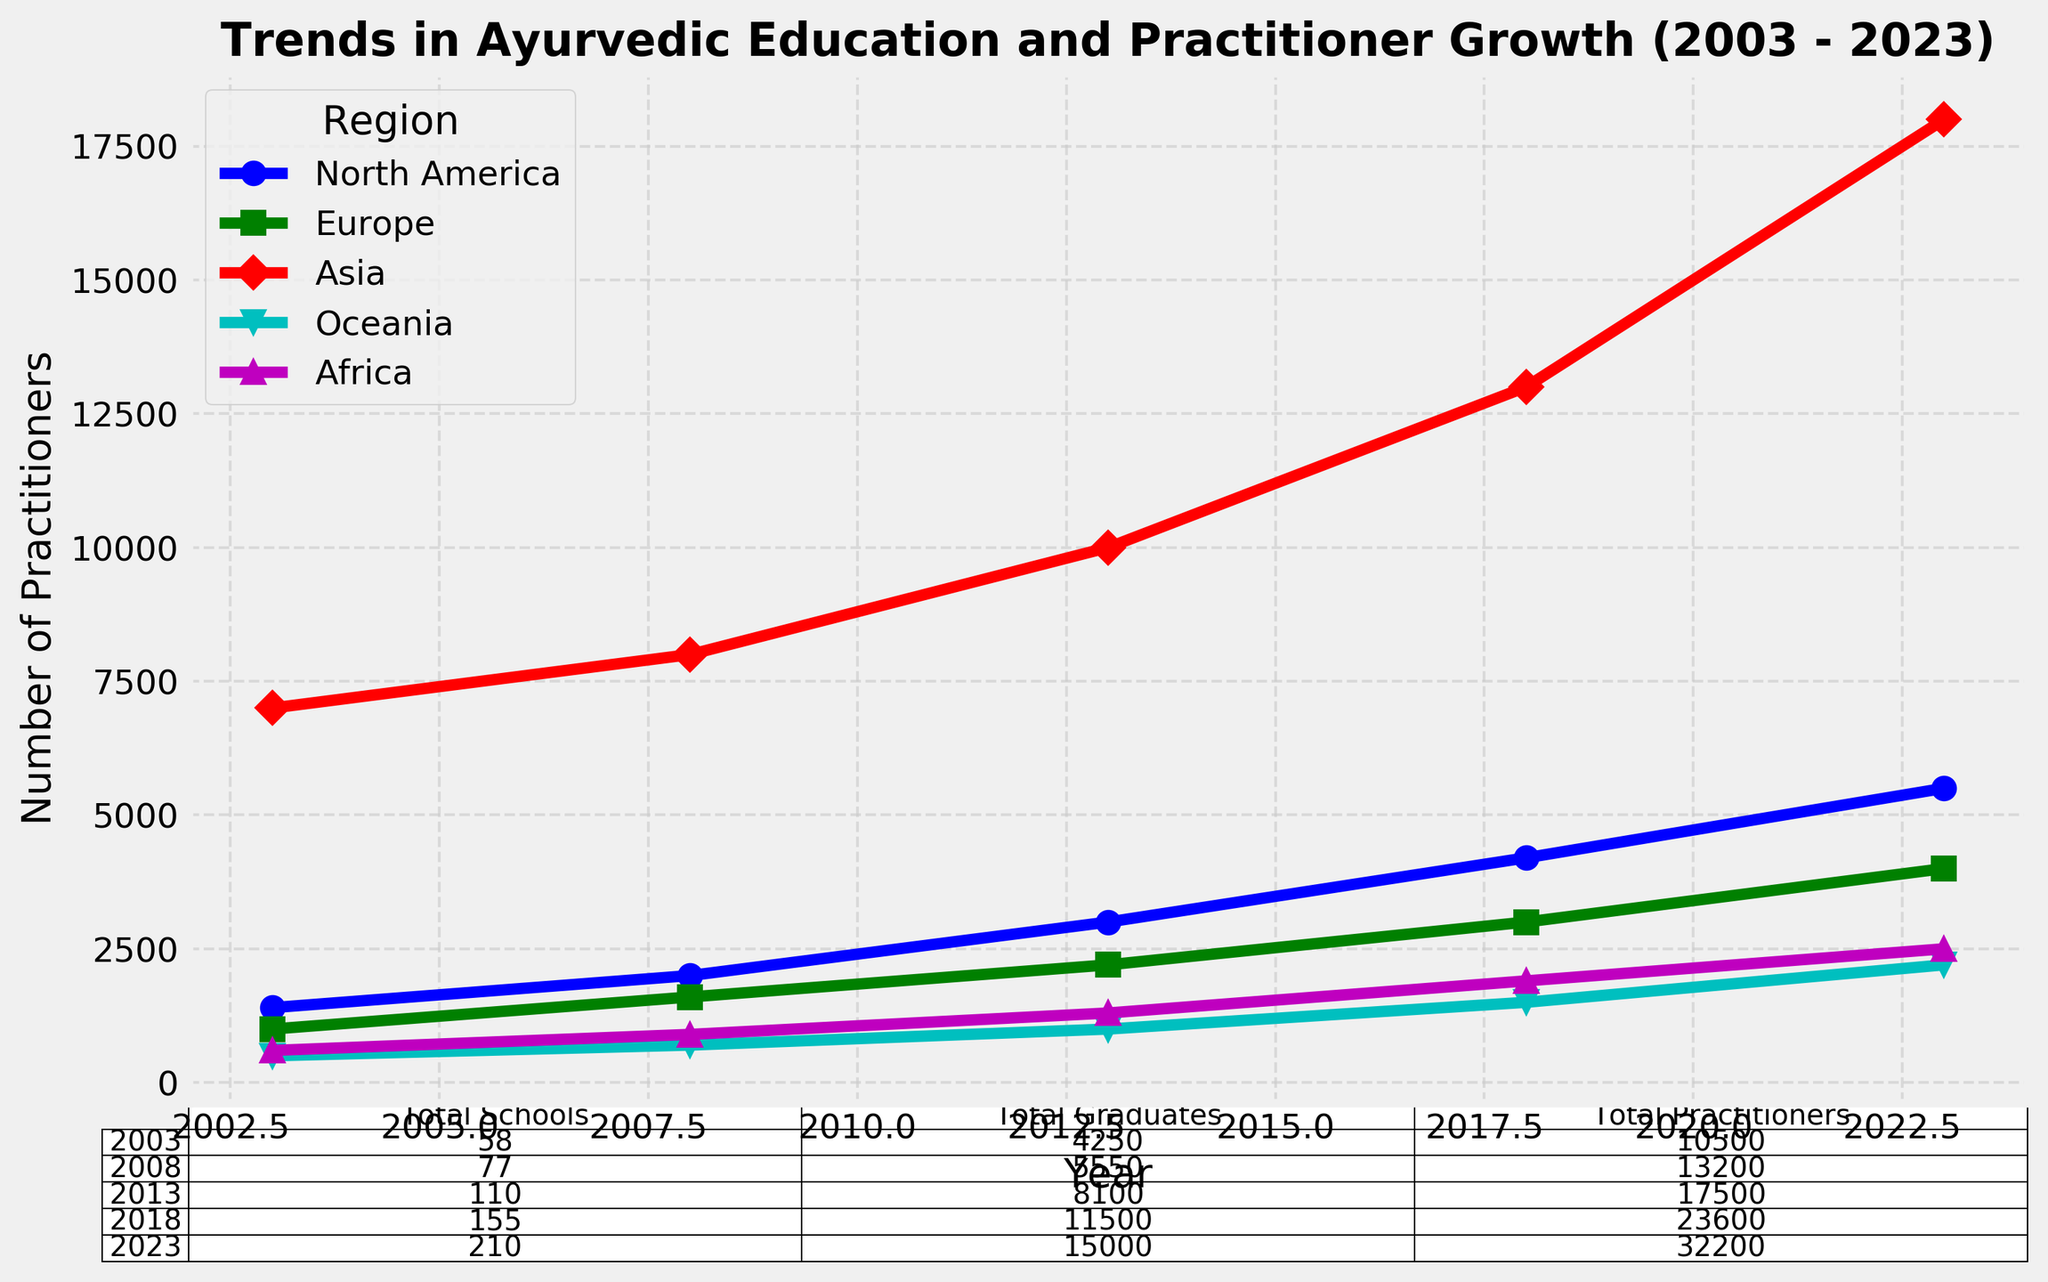What is the total number of Ayurvedic schools across all regions in 2008? From the table, we look at the row corresponding to the year 2008 and sum the "Total Schools" column, which is 20 + 15 + 25 + 7 + 10 = 77.
Answer: 77 Which region had the largest increase in the number of practitioners from 2003 to 2023? We compare the number of practitioners in 2023 to 2003 for each region: North America (5500 - 1400 = 4100), Europe (4000 - 1000 = 3000), Asia (18000 - 7000 = 11000), Oceania (2200 - 500 = 1700), and Africa (2500 - 600 = 1900). Asia shows the largest increase.
Answer: Asia In 2018, how many more Ayurvedic graduates were there in Europe compared to Oceania? We check the "Number of Graduates" for Europe and Oceania in 2018, which are 1500 and 600 respectively. The difference is 1500 - 600 = 900.
Answer: 900 Which year had the highest total number of Ayurvedic practitioners globally? From the table, we add the "Total Practitioners" values for each year and compare them. 2023 has the highest total, with 5500 + 4000 + 18000 + 2200 + 2500 = 32200.
Answer: 2023 What is the total number of graduates in Asia over the 20-year period? Sum the "Number of Graduates" in Asia for all the years: 3000 (2003) + 3500 (2008) + 5000 (2013) + 7000 (2018) + 9000 (2023) = 27500.
Answer: 27500 Which region had the greatest relative increase in the number of Ayurvedic schools from 2003 to 2023? We calculate the relative increase for each region: North America (50-15)/15 = 2.33, Europe (40-10)/10 = 3.00, Asia (70-20)/20 = 2.50, Oceania (20-5)/5 = 3.00, Africa (30-8)/8 ≈ 2.75. Europe and Oceania have the greatest relative increase at 3.00.
Answer: Europe and Oceania What color represents Europe on the plot? By looking at the plot legend, we identify the color used for Europe.
Answer: green In which year did Asia have its highest number of Ayurvedic graduates and how many were there? Referring to the plot, Asia had the highest number of graduates in 2023 with 9000 graduates.
Answer: 2023, 9000 